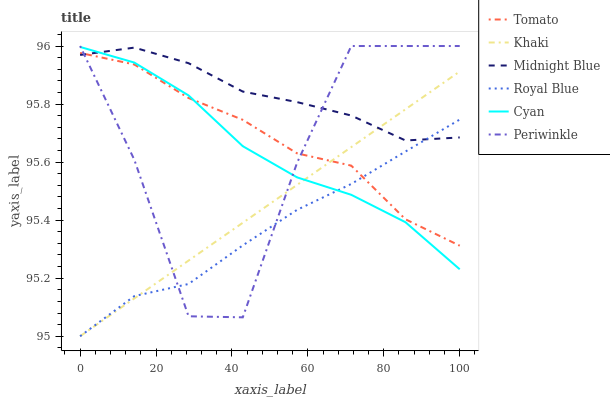Does Royal Blue have the minimum area under the curve?
Answer yes or no. Yes. Does Midnight Blue have the maximum area under the curve?
Answer yes or no. Yes. Does Khaki have the minimum area under the curve?
Answer yes or no. No. Does Khaki have the maximum area under the curve?
Answer yes or no. No. Is Khaki the smoothest?
Answer yes or no. Yes. Is Periwinkle the roughest?
Answer yes or no. Yes. Is Midnight Blue the smoothest?
Answer yes or no. No. Is Midnight Blue the roughest?
Answer yes or no. No. Does Khaki have the lowest value?
Answer yes or no. Yes. Does Midnight Blue have the lowest value?
Answer yes or no. No. Does Periwinkle have the highest value?
Answer yes or no. Yes. Does Khaki have the highest value?
Answer yes or no. No. Does Cyan intersect Tomato?
Answer yes or no. Yes. Is Cyan less than Tomato?
Answer yes or no. No. Is Cyan greater than Tomato?
Answer yes or no. No. 